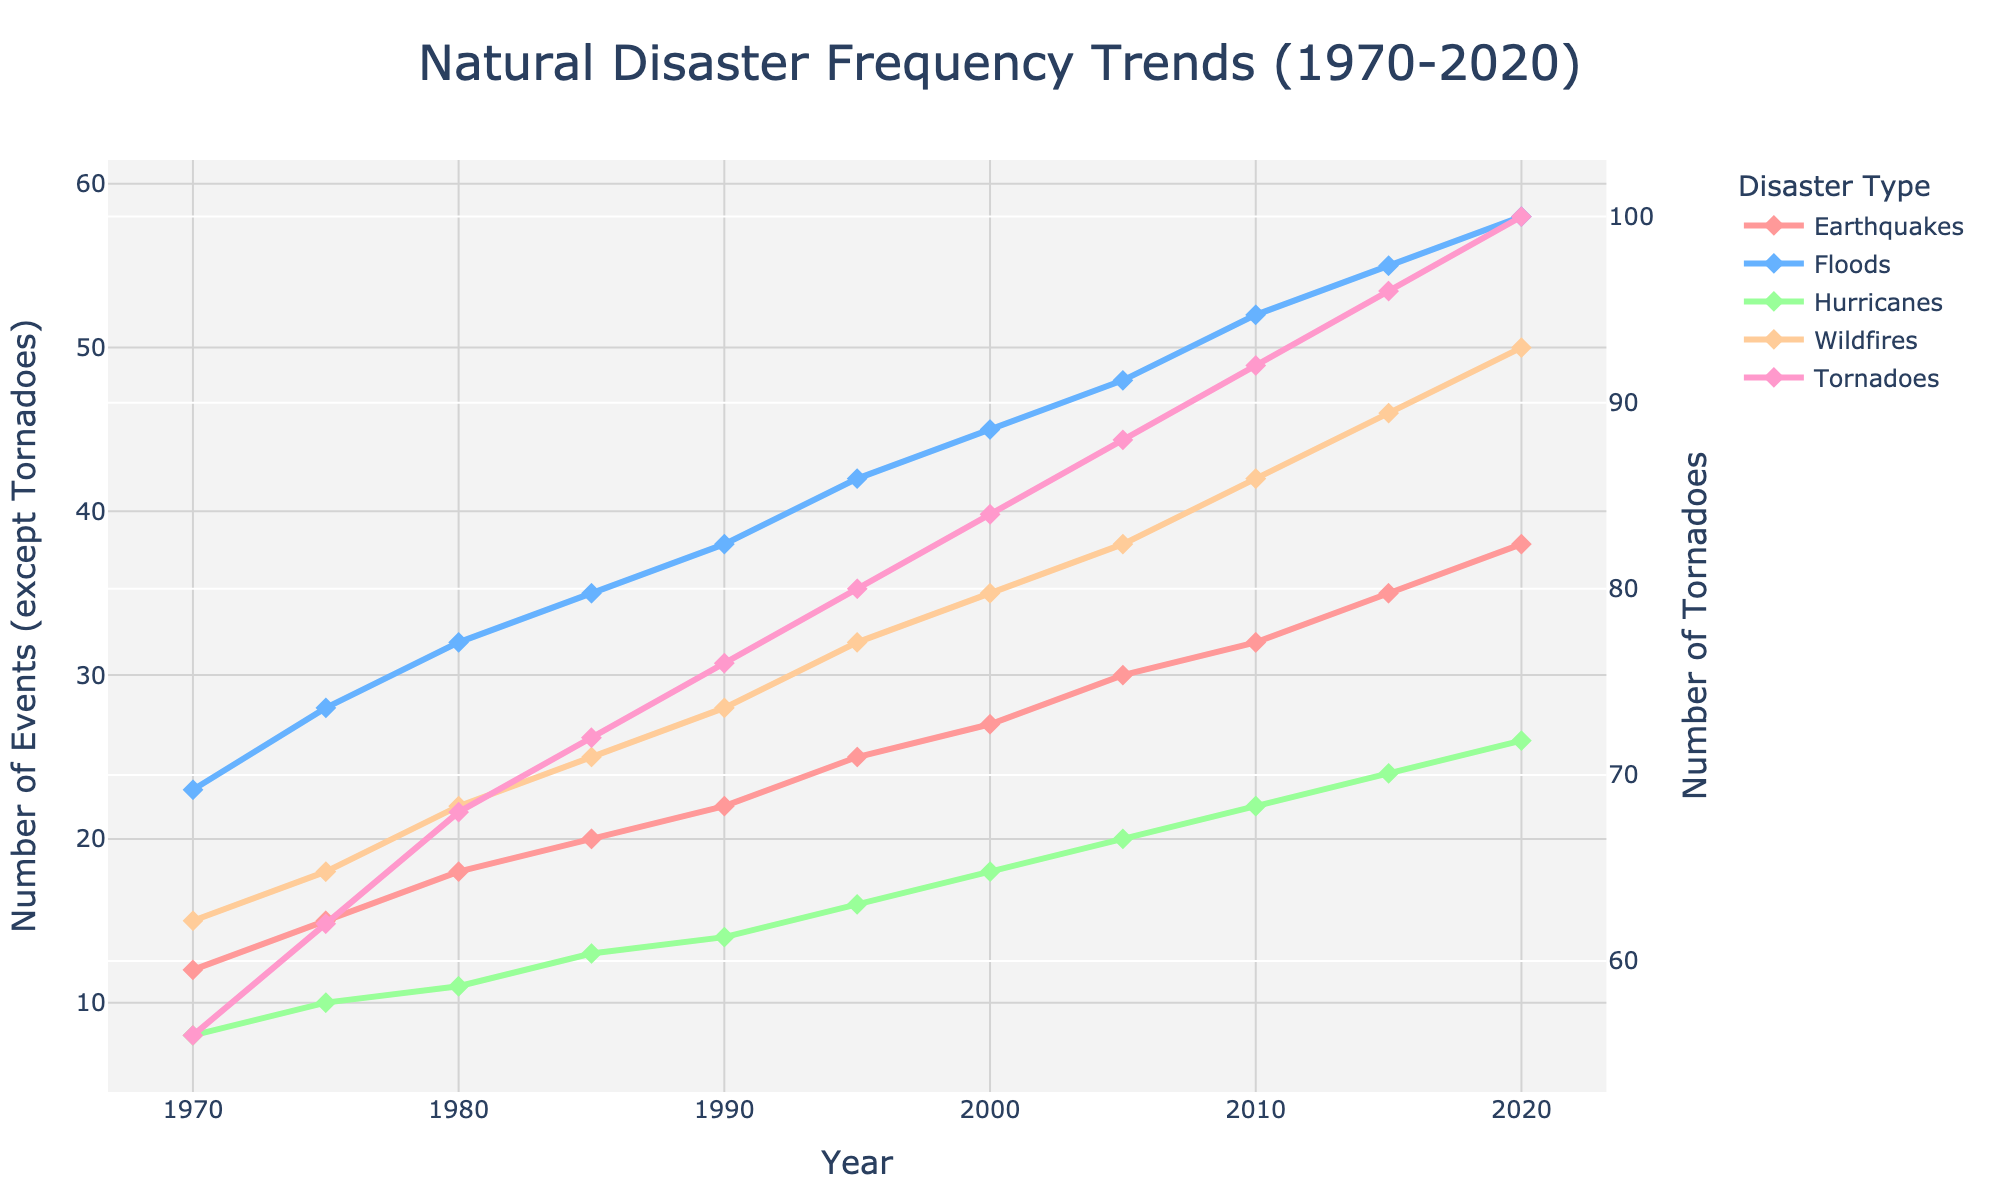What is the overall trend in the frequency of earthquakes from 1970 to 2020? The frequency of earthquakes shows a gradual increase over the period from 1970 to 2020. Observing the line representing earthquakes, it starts at 12 events in 1970 and increases to 38 events by 2020.
Answer: Increasing How does the number of tornadoes in 1990 compare with the number of hurricanes in the same year? In 1990, the figure shows that the number of tornadoes is approximately 76, while the number of hurricanes is around 14.
Answer: Tornadoes are much higher What is the average number of floods reported in the years 1970, 1980, and 1990? To calculate the average, sum the number of floods for the years 1970 (23), 1980 (32), and 1990 (38), which is 93. Then divide by 3 to find the average: 93 / 3 = 31.
Answer: 31 Which disaster type has shown the most significant increase in frequency over the past 50 years? By comparing the slopes of the lines for each disaster type, tornadoes have shown the largest increase from 56 in 1970 to 100 in 2020.
Answer: Tornadoes In which year did wildfires surpass 40 events, and how many years did it take from 1970? Wildfires surpassed 40 events in 2010. From 1970, it took 40 years to reach this point.
Answer: 2010, 40 years Between 1980 and 2000, which natural disaster type had the least growth in frequency? Comparing the difference in the number of events between 1980 and 2000 for all disaster types: Earthquakes (9), Floods (13), Hurricanes (7), Wildfires (13), Tornadoes (16). Hurricanes had the least growth.
Answer: Hurricanes By how many events did floods increase from 1985 to 2005? The number of floods in 1985 was 35 and in 2005 it was 48. The increase is 48 - 35 = 13.
Answer: 13 What are the two disaster types with the highest frequency in 2005 and how do they compare? In 2005, tornadoes (88) and floods (48) have the highest frequencies. Tornadoes are almost twice as frequent as floods.
Answer: Tornadoes and Floods, Tornadoes are almost twice What is the difference in the number of hurricanes between the year 1980 and 2020? In 1980, the number of hurricanes is 11, and in 2020 it is 26. The difference is 26 - 11 = 15.
Answer: 15 Which year marks the first instance when the number of earthquakes reached 30 events? The number of earthquakes first reached 30 in 2005. Observing the line for earthquakes, this milestone is visible at that year.
Answer: 2005 